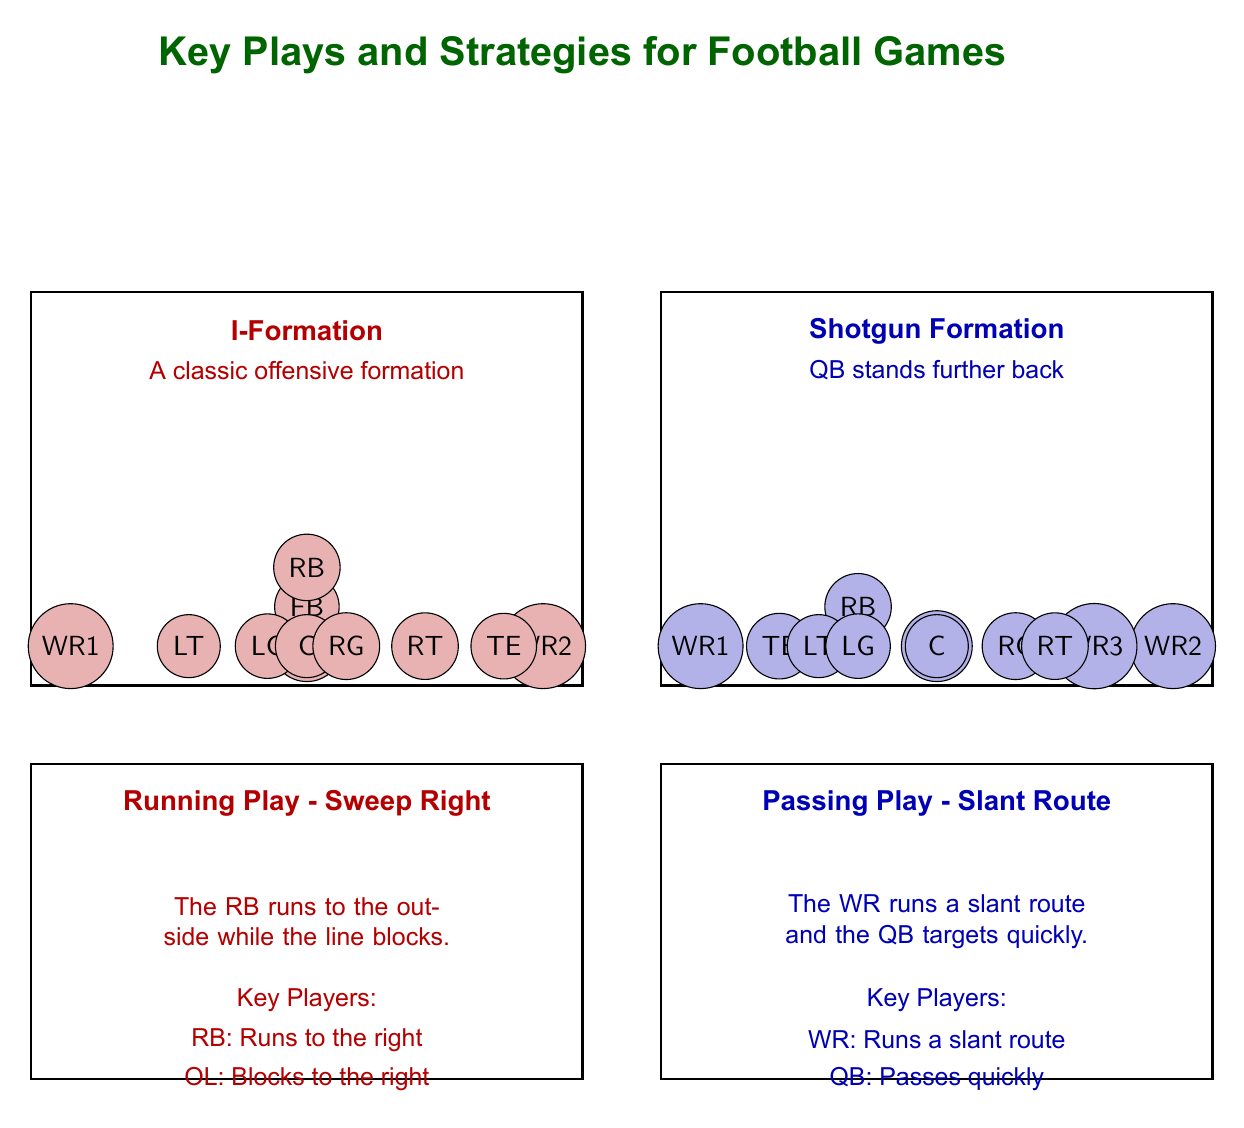What is the title of the diagram? The title is prominently displayed at the top of the diagram and states the main topic it covers, which is indicated by the text 'Key Plays and Strategies for Football Games'.
Answer: Key Plays and Strategies for Football Games How many players are in the I-Formation? The I-Formation consists of 10 player positions, which are visually represented in the left rectangle of the diagram. The positions include QB, FB, RB, WR1, WR2, TE, LT, LG, C, RG, and RT.
Answer: 10 Which play is associated with the jersey red color? The jersey red color is used to represent both the I-Formation and the Running Play - Sweep Right. The visual representation makes it clear that this color corresponds to the offensive formation and the specific play.
Answer: Running Play - Sweep Right What route does the Wide Receiver run in the Passing Play? The diagram explicitly states that in the Passing Play - Slant Route, the Wide Receiver is responsible for running a slant route. This is directly mentioned in the key players' section of the passing play.
Answer: Slant route Who is the key player responsible for running the ball in the Running Play? The Running Back (RB) is identified as the key player in the Running Play - Sweep Right, tasked with running to the right as outlined in the key players' details.
Answer: RB What formation does the Quarterback (QB) stand in during the Shotgun Formation? The diagram shows the Shotgun Formation, where the Quarterback (QB) stands further back compared to the traditional formations, as described in the formation's label.
Answer: Shotgun Formation What does OL represent in the Running Play - Sweep Right? In the Running Play - Sweep Right, OL stands for the offensive line, which is responsible for blocking to create a pathway for the Running Back as stated in the key players' list.
Answer: Offensive line How many Wide Receivers are there in the Shotgun Formation? The Shotgun Formation includes three Wide Receiver positions (WR1, WR2, and WR3) as indicated in the arrangement of players within that specific formation in the diagram.
Answer: 3 Which formation allows the QB to stand further back? The diagram mentions that the Shotgun Formation is characterized by the Quarterback standing further back, differentiating it from other formations like the I-Formation.
Answer: Shotgun Formation 